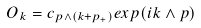Convert formula to latex. <formula><loc_0><loc_0><loc_500><loc_500>O _ { k } = c _ { p \wedge ( k + p _ { + } ) } e x p ( i k \wedge p )</formula> 